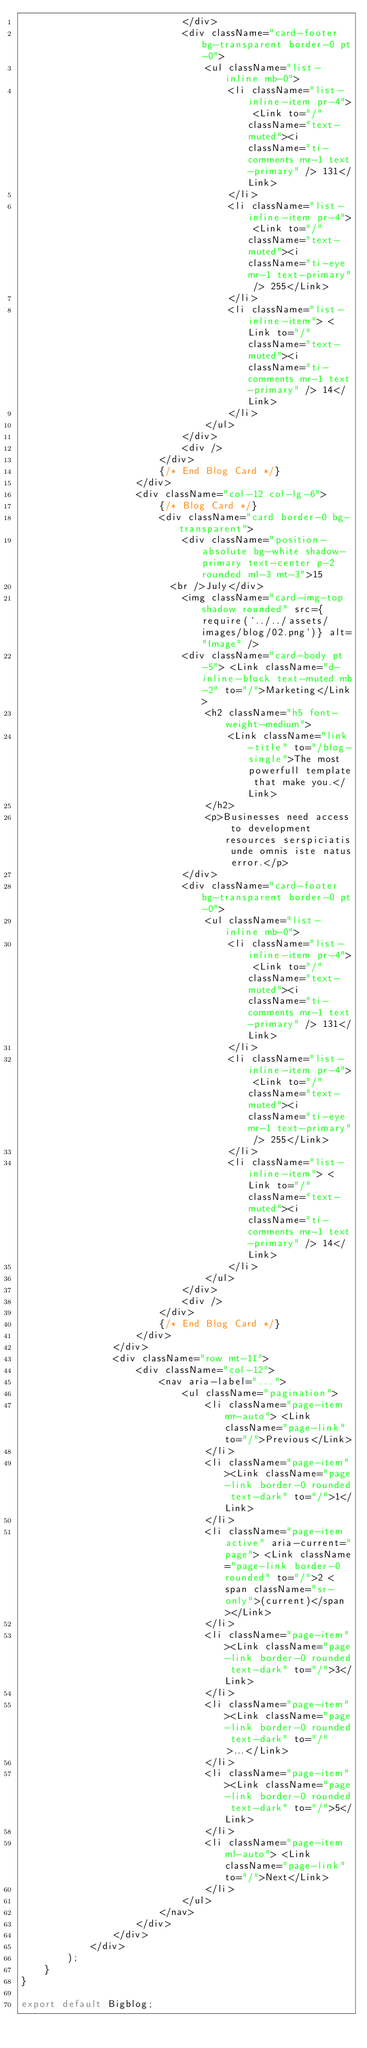<code> <loc_0><loc_0><loc_500><loc_500><_JavaScript_>                            </div>
                            <div className="card-footer bg-transparent border-0 pt-0">
                                <ul className="list-inline mb-0">
                                    <li className="list-inline-item pr-4"> <Link to="/" className="text-muted"><i className="ti-comments mr-1 text-primary" /> 131</Link>
                                    </li>
                                    <li className="list-inline-item pr-4"> <Link to="/" className="text-muted"><i className="ti-eye mr-1 text-primary" /> 255</Link>
                                    </li>
                                    <li className="list-inline-item"> <Link to="/" className="text-muted"><i className="ti-comments mr-1 text-primary" /> 14</Link>
                                    </li>
                                </ul>
                            </div>
                            <div />
                        </div>
                        {/* End Blog Card */}
                    </div>
                    <div className="col-12 col-lg-6">
                        {/* Blog Card */}
                        <div className="card border-0 bg-transparent">
                            <div className="position-absolute bg-white shadow-primary text-center p-2 rounded ml-3 mt-3">15
                          <br />July</div>
                            <img className="card-img-top shadow rounded" src={require(`../../assets/images/blog/02.png`)} alt="Image" />
                            <div className="card-body pt-5"> <Link className="d-inline-block text-muted mb-2" to="/">Marketing</Link>
                                <h2 className="h5 font-weight-medium">
                                    <Link className="link-title" to="/blog-single">The most powerfull template that make you.</Link>
                                </h2>
                                <p>Businesses need access to development resources serspiciatis unde omnis iste natus error.</p>
                            </div>
                            <div className="card-footer bg-transparent border-0 pt-0">
                                <ul className="list-inline mb-0">
                                    <li className="list-inline-item pr-4"> <Link to="/" className="text-muted"><i className="ti-comments mr-1 text-primary" /> 131</Link>
                                    </li>
                                    <li className="list-inline-item pr-4"> <Link to="/" className="text-muted"><i className="ti-eye mr-1 text-primary" /> 255</Link>
                                    </li>
                                    <li className="list-inline-item"> <Link to="/" className="text-muted"><i className="ti-comments mr-1 text-primary" /> 14</Link>
                                    </li>
                                </ul>
                            </div>
                            <div />
                        </div>
                        {/* End Blog Card */}
                    </div>
                </div>
                <div className="row mt-11">
                    <div className="col-12">
                        <nav aria-label="...">
                            <ul className="pagination">
                                <li className="page-item mr-auto"> <Link className="page-link" to="/">Previous</Link>
                                </li>
                                <li className="page-item"><Link className="page-link border-0 rounded text-dark" to="/">1</Link>
                                </li>
                                <li className="page-item active" aria-current="page"> <Link className="page-link border-0 rounded" to="/">2 <span className="sr-only">(current)</span></Link>
                                </li>
                                <li className="page-item"><Link className="page-link border-0 rounded text-dark" to="/">3</Link>
                                </li>
                                <li className="page-item"><Link className="page-link border-0 rounded text-dark" to="/">...</Link>
                                </li>
                                <li className="page-item"><Link className="page-link border-0 rounded text-dark" to="/">5</Link>
                                </li>
                                <li className="page-item ml-auto"> <Link className="page-link" to="/">Next</Link>
                                </li>
                            </ul>
                        </nav>
                    </div>
                </div>
            </div>
        );
    }
}

export default Bigblog;</code> 